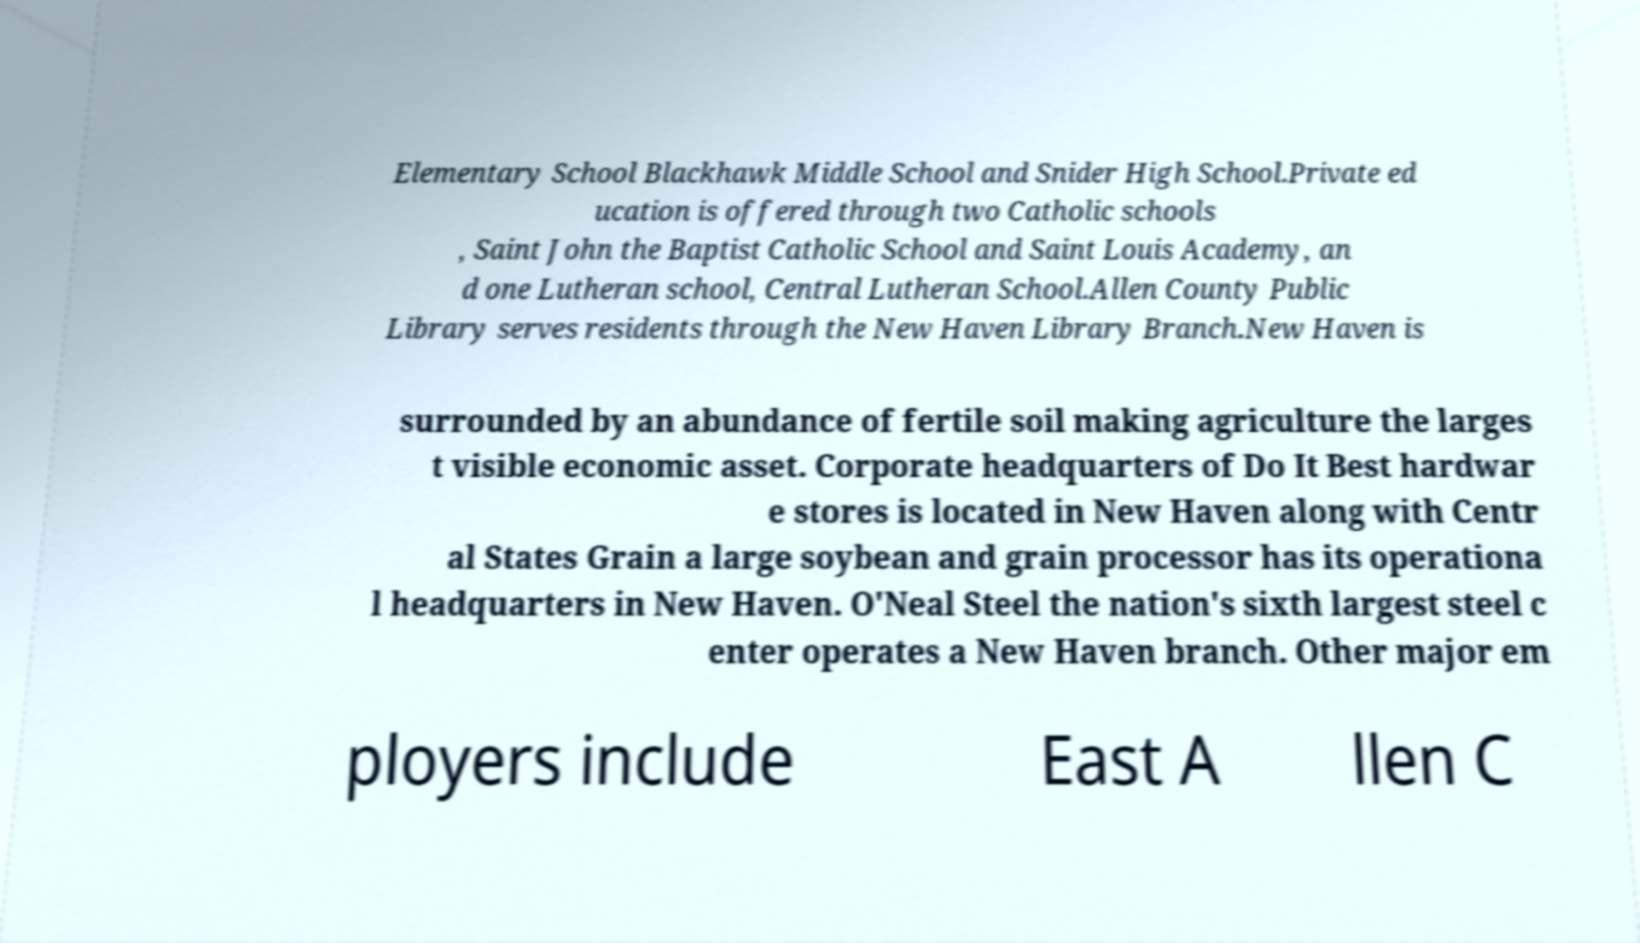Could you extract and type out the text from this image? Elementary School Blackhawk Middle School and Snider High School.Private ed ucation is offered through two Catholic schools , Saint John the Baptist Catholic School and Saint Louis Academy, an d one Lutheran school, Central Lutheran School.Allen County Public Library serves residents through the New Haven Library Branch.New Haven is surrounded by an abundance of fertile soil making agriculture the larges t visible economic asset. Corporate headquarters of Do It Best hardwar e stores is located in New Haven along with Centr al States Grain a large soybean and grain processor has its operationa l headquarters in New Haven. O'Neal Steel the nation's sixth largest steel c enter operates a New Haven branch. Other major em ployers include East A llen C 